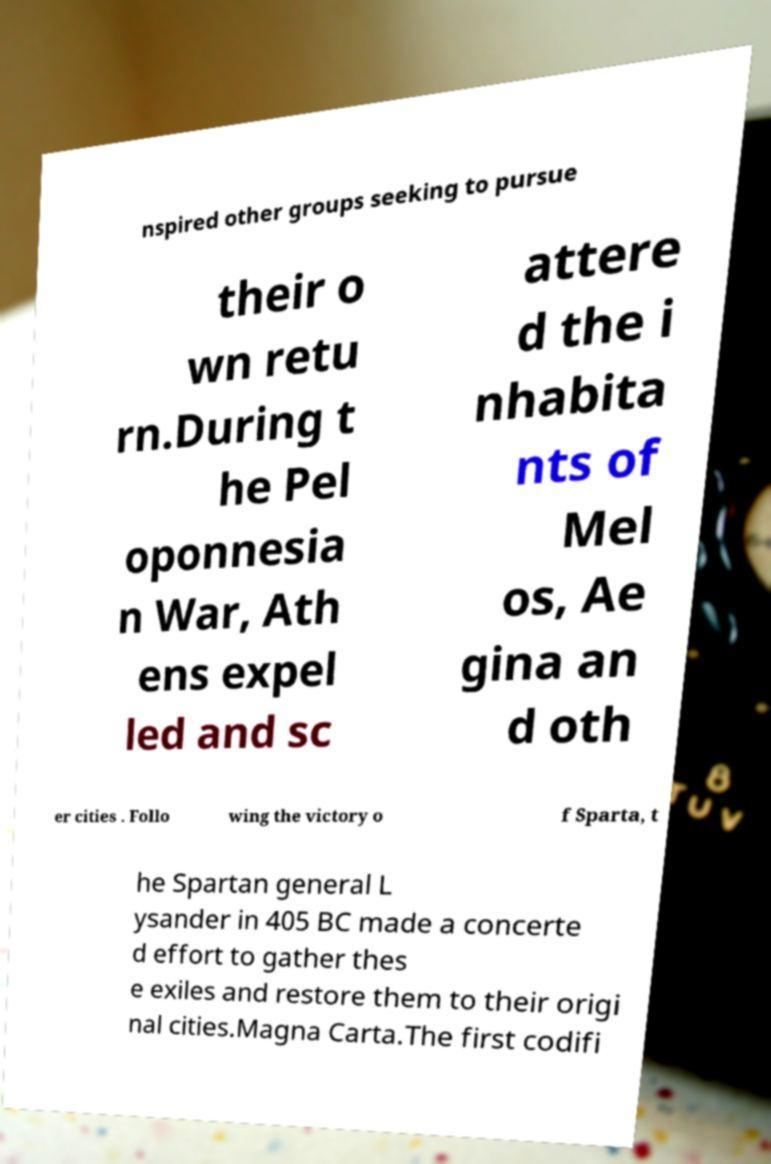What messages or text are displayed in this image? I need them in a readable, typed format. nspired other groups seeking to pursue their o wn retu rn.During t he Pel oponnesia n War, Ath ens expel led and sc attere d the i nhabita nts of Mel os, Ae gina an d oth er cities . Follo wing the victory o f Sparta, t he Spartan general L ysander in 405 BC made a concerte d effort to gather thes e exiles and restore them to their origi nal cities.Magna Carta.The first codifi 